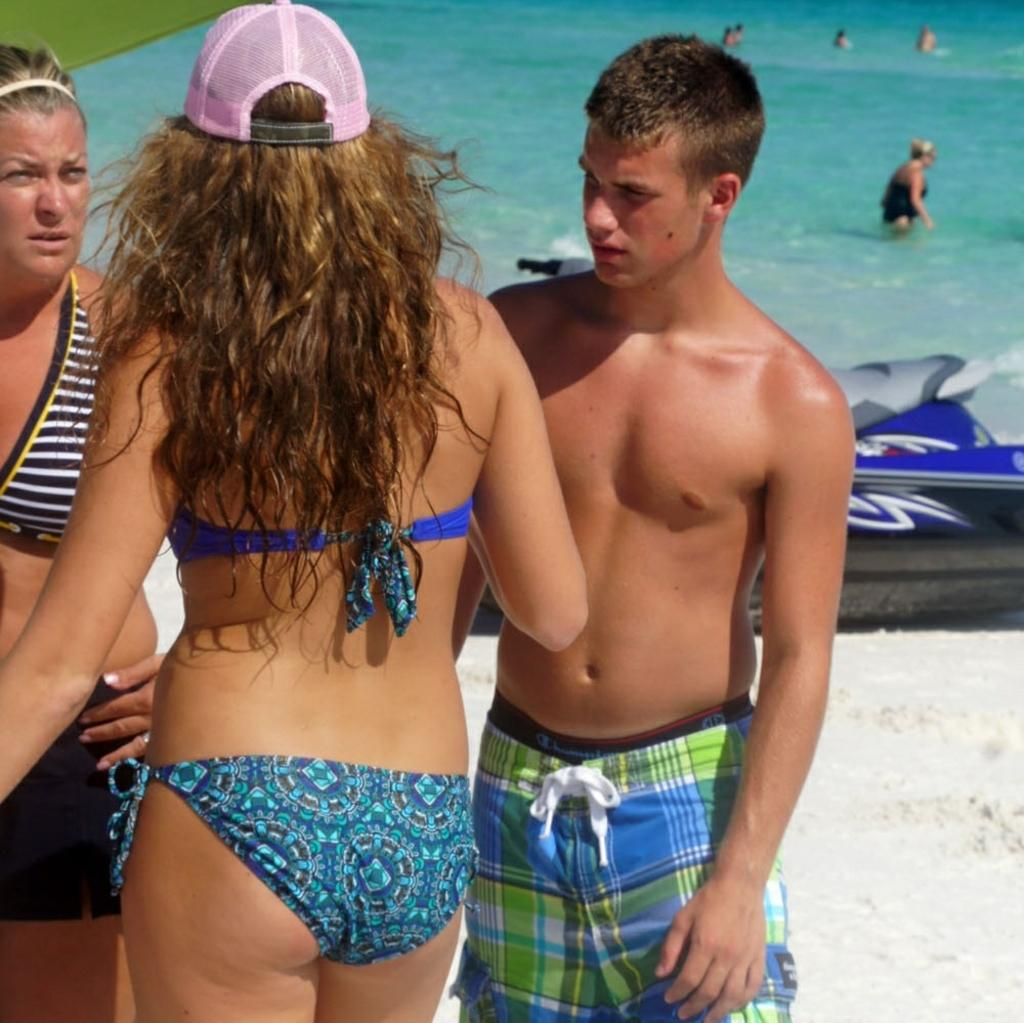How many people are in the image? The number of people in the image is not specified, but there are people present. What can be seen in the image besides the people? There is a swimming pool and grass visible in the image. What type of milk is being served in the image? There is no milk present in the image; it features people, a swimming pool, and grass. 